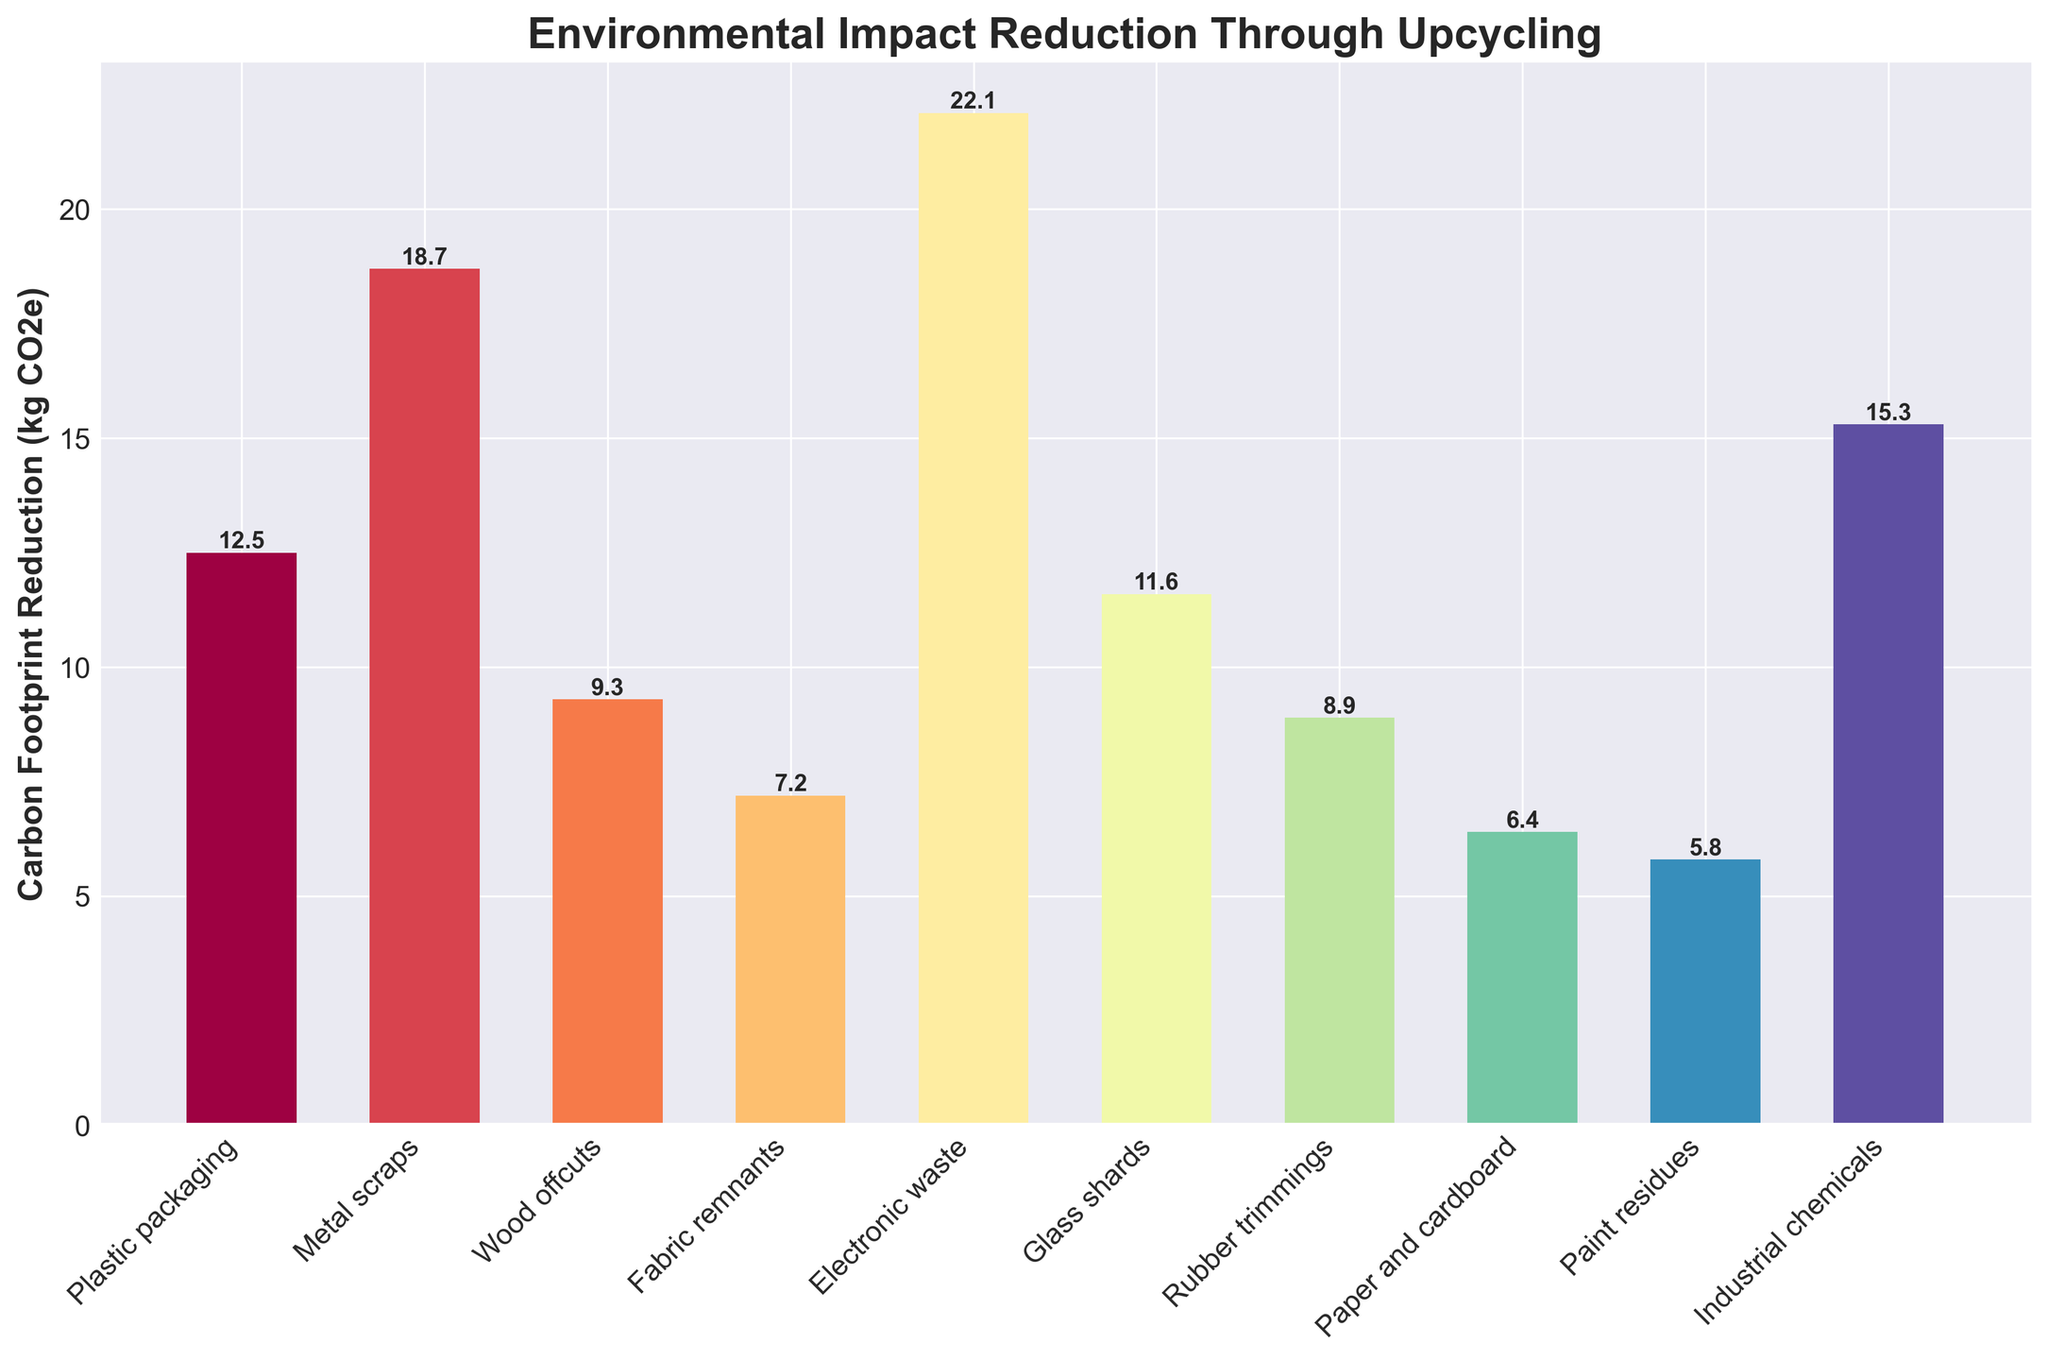What material achieves the highest carbon footprint reduction? The bar representing electronic waste is the tallest, indicating it has the highest carbon footprint reduction.
Answer: Electronic waste Which material has the lowest carbon footprint reduction? The bar representing paint residues is the shortest, indicating it has the lowest carbon footprint reduction.
Answer: Paint residues How much greater is the carbon footprint reduction from metal scraps compared to plastic packaging? The reduction for metal scraps is 18.7 kg CO2e, and for plastic packaging, it is 12.5 kg CO2e. The difference is 18.7 - 12.5.
Answer: 6.2 kg CO2e What is the combined carbon footprint reduction for fabric remnants and rubber trimmings? The reduction for fabric remnants is 7.2 kg CO2e and for rubber trimmings is 8.9 kg CO2e. The sum is 7.2 + 8.9.
Answer: 16.1 kg CO2e Which two materials have the closest carbon footprint reductions? By comparing the heights of the bars, plastic packaging (12.5 kg CO2e) and glass shards (11.6 kg CO2e) are close.
Answer: Plastic packaging and glass shards What is the average carbon footprint reduction across all materials? Sum all the reductions and divide by the number of materials. The total sum is 12.5 + 18.7 + 9.3 + 7.2 + 22.1 + 11.6 + 8.9 + 6.4 + 5.8 + 15.3, which equals 117.8 kg CO2e. Divide by 10.
Answer: 11.8 kg CO2e Rank the materials from highest to lowest in terms of carbon footprint reduction. List the materials based on the height of their respective bars: electronic waste, metal scraps, industrial chemicals, plastic packaging, glass shards, wood offcuts, rubber trimmings, fabric remnants, paper and cardboard, paint residues.
Answer: Electronic waste, metal scraps, industrial chemicals, plastic packaging, glass shards, wood offcuts, rubber trimmings, fabric remnants, paper and cardboard, paint residues How does the carbon footprint reduction of industrial chemicals compare to glass shards? The reduction for industrial chemicals is higher than for glass shards.
Answer: Higher What is the total carbon footprint reduction achieved by upcycling the top 3 materials? The top 3 materials are electronic waste (22.1 kg CO2e), metal scraps (18.7 kg CO2e), and industrial chemicals (15.3 kg CO2e). The total is 22.1 + 18.7 + 15.3.
Answer: 56.1 kg CO2e 